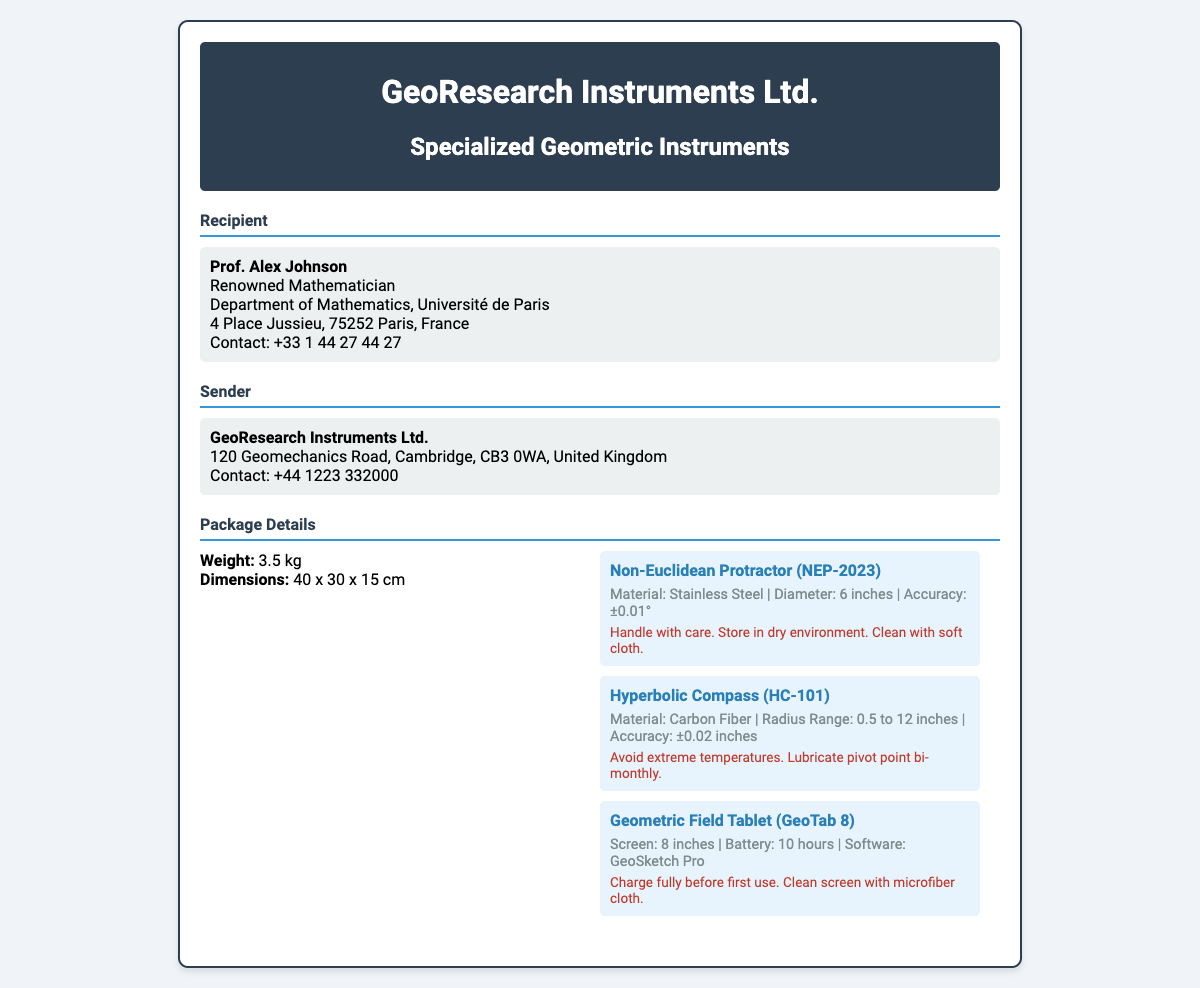What is the weight of the package? The weight of the package is explicitly mentioned in the document.
Answer: 3.5 kg Who is the recipient of the package? The recipient's name is clearly stated in the address section of the document.
Answer: Prof. Alex Johnson What is the material of the Non-Euclidean Protractor? The material used for the Non-Euclidean Protractor is specified in the package details.
Answer: Stainless Steel What is the radius range of the Hyperbolic Compass? The radius range of the Hyperbolic Compass can be found in the specifications listed in the document.
Answer: 0.5 to 12 inches What should you do before the first use of the Geometric Field Tablet? The handling instruction for the Geometric Field Tablet provides this information.
Answer: Charge fully What is the contact number for the sender? The contact number for the sender is included in the address section of the document.
Answer: +44 1223 332000 What is the accuracy of the Non-Euclidean Protractor? The accuracy of the Non-Euclidean Protractor is given in the specifications section.
Answer: ±0.01° What type of software is included with the Geometric Field Tablet? The specific software included with the Geometric Field Tablet is specified in the document.
Answer: GeoSketch Pro What is the designed handling reminder for the Hyperbolic Compass? The handling instruction for the Hyperbolic Compass gives this guidance.
Answer: Avoid extreme temperatures 